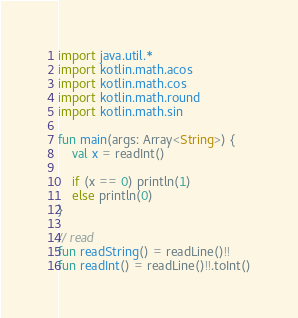<code> <loc_0><loc_0><loc_500><loc_500><_Kotlin_>import java.util.*
import kotlin.math.acos
import kotlin.math.cos
import kotlin.math.round
import kotlin.math.sin

fun main(args: Array<String>) {
    val x = readInt()
    
    if (x == 0) println(1)
    else println(0)
}

// read
fun readString() = readLine()!!
fun readInt() = readLine()!!.toInt()</code> 